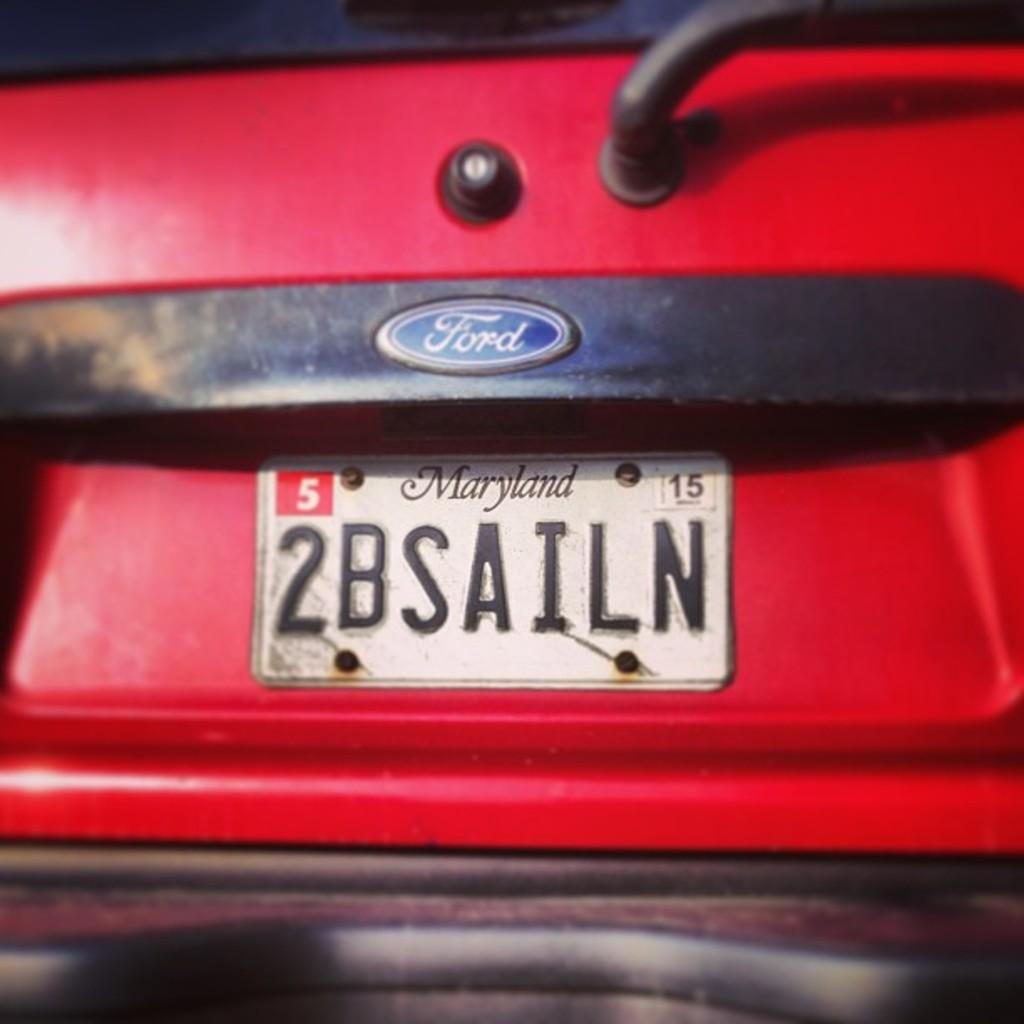<image>
Create a compact narrative representing the image presented. A Maryland personalized license plate on a red vehicle that reads "2BSAILN". 